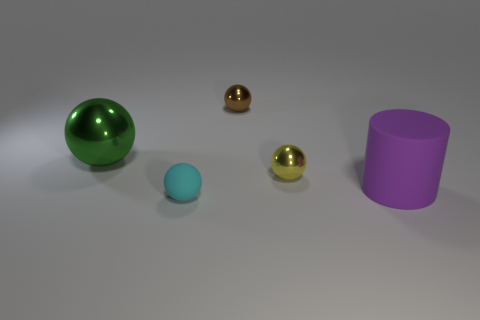Subtract 1 spheres. How many spheres are left? 3 Subtract all tiny brown shiny balls. How many balls are left? 3 Subtract all green balls. How many balls are left? 3 Add 4 green metallic objects. How many objects exist? 9 Subtract all blue spheres. Subtract all cyan cubes. How many spheres are left? 4 Subtract all cylinders. How many objects are left? 4 Add 5 tiny metallic balls. How many tiny metallic balls are left? 7 Add 5 small yellow metal objects. How many small yellow metal objects exist? 6 Subtract 0 purple balls. How many objects are left? 5 Subtract all tiny spheres. Subtract all big gray things. How many objects are left? 2 